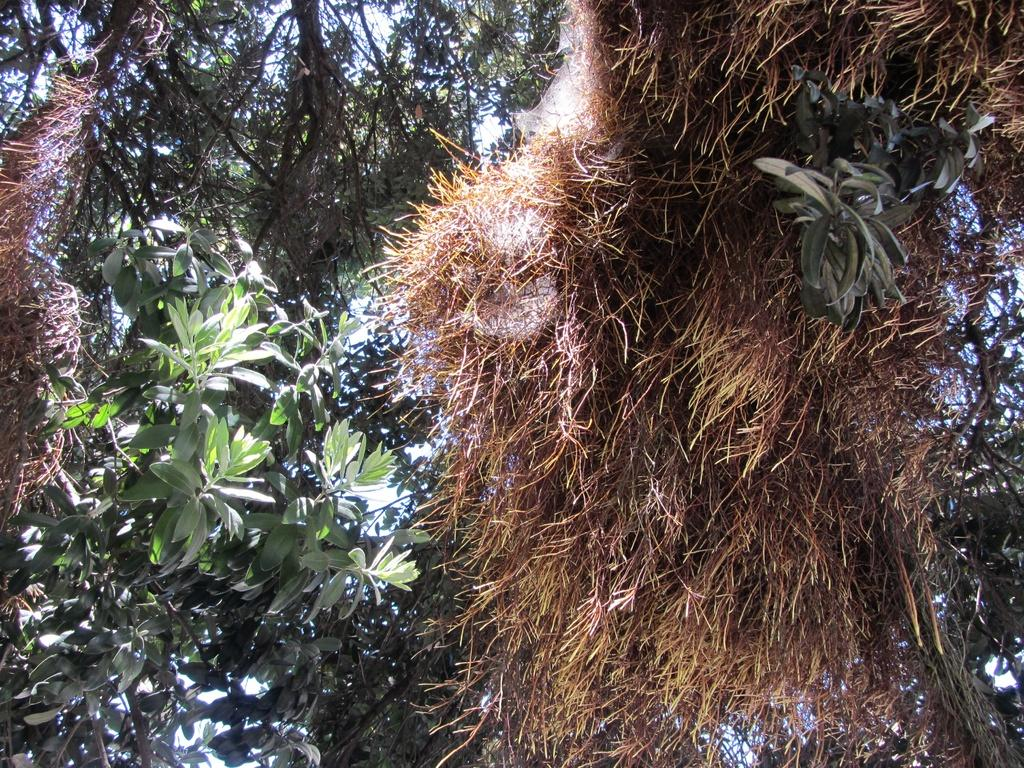What can be seen in the background of the image? There is sky visible in the image. What type of vegetation is present in the image? There are trees in the image. What type of ground cover is present in the image? There is grass in the image. How many babies are touching the trees in the image? There are no babies present in the image, and therefore no babies can be seen touching the trees. 